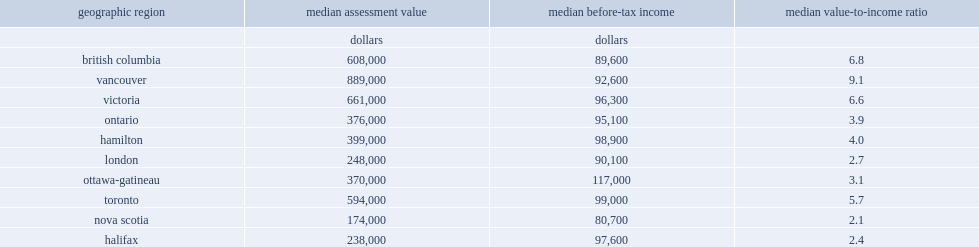Which region had the assessment value-to-income ratio? British columbia 608000. How many times in the vancouver cma where property values were greater than the income of owners? 9.1. In ontario, which region had the highest value-to-income ratio? Toronto 5.7. In ontario, the highest value-to-income ratio was in the toronto, how many times in toronto cma where property values were greater than the income of owners? 5.7. Among all cmas in the three provinces, which region had the highest median income of property owners in ontario part? Ottawa-gatineau. Which region had the lower value-to-income ratio, in the cma or the provincial level? Median value-to-income ratio. 